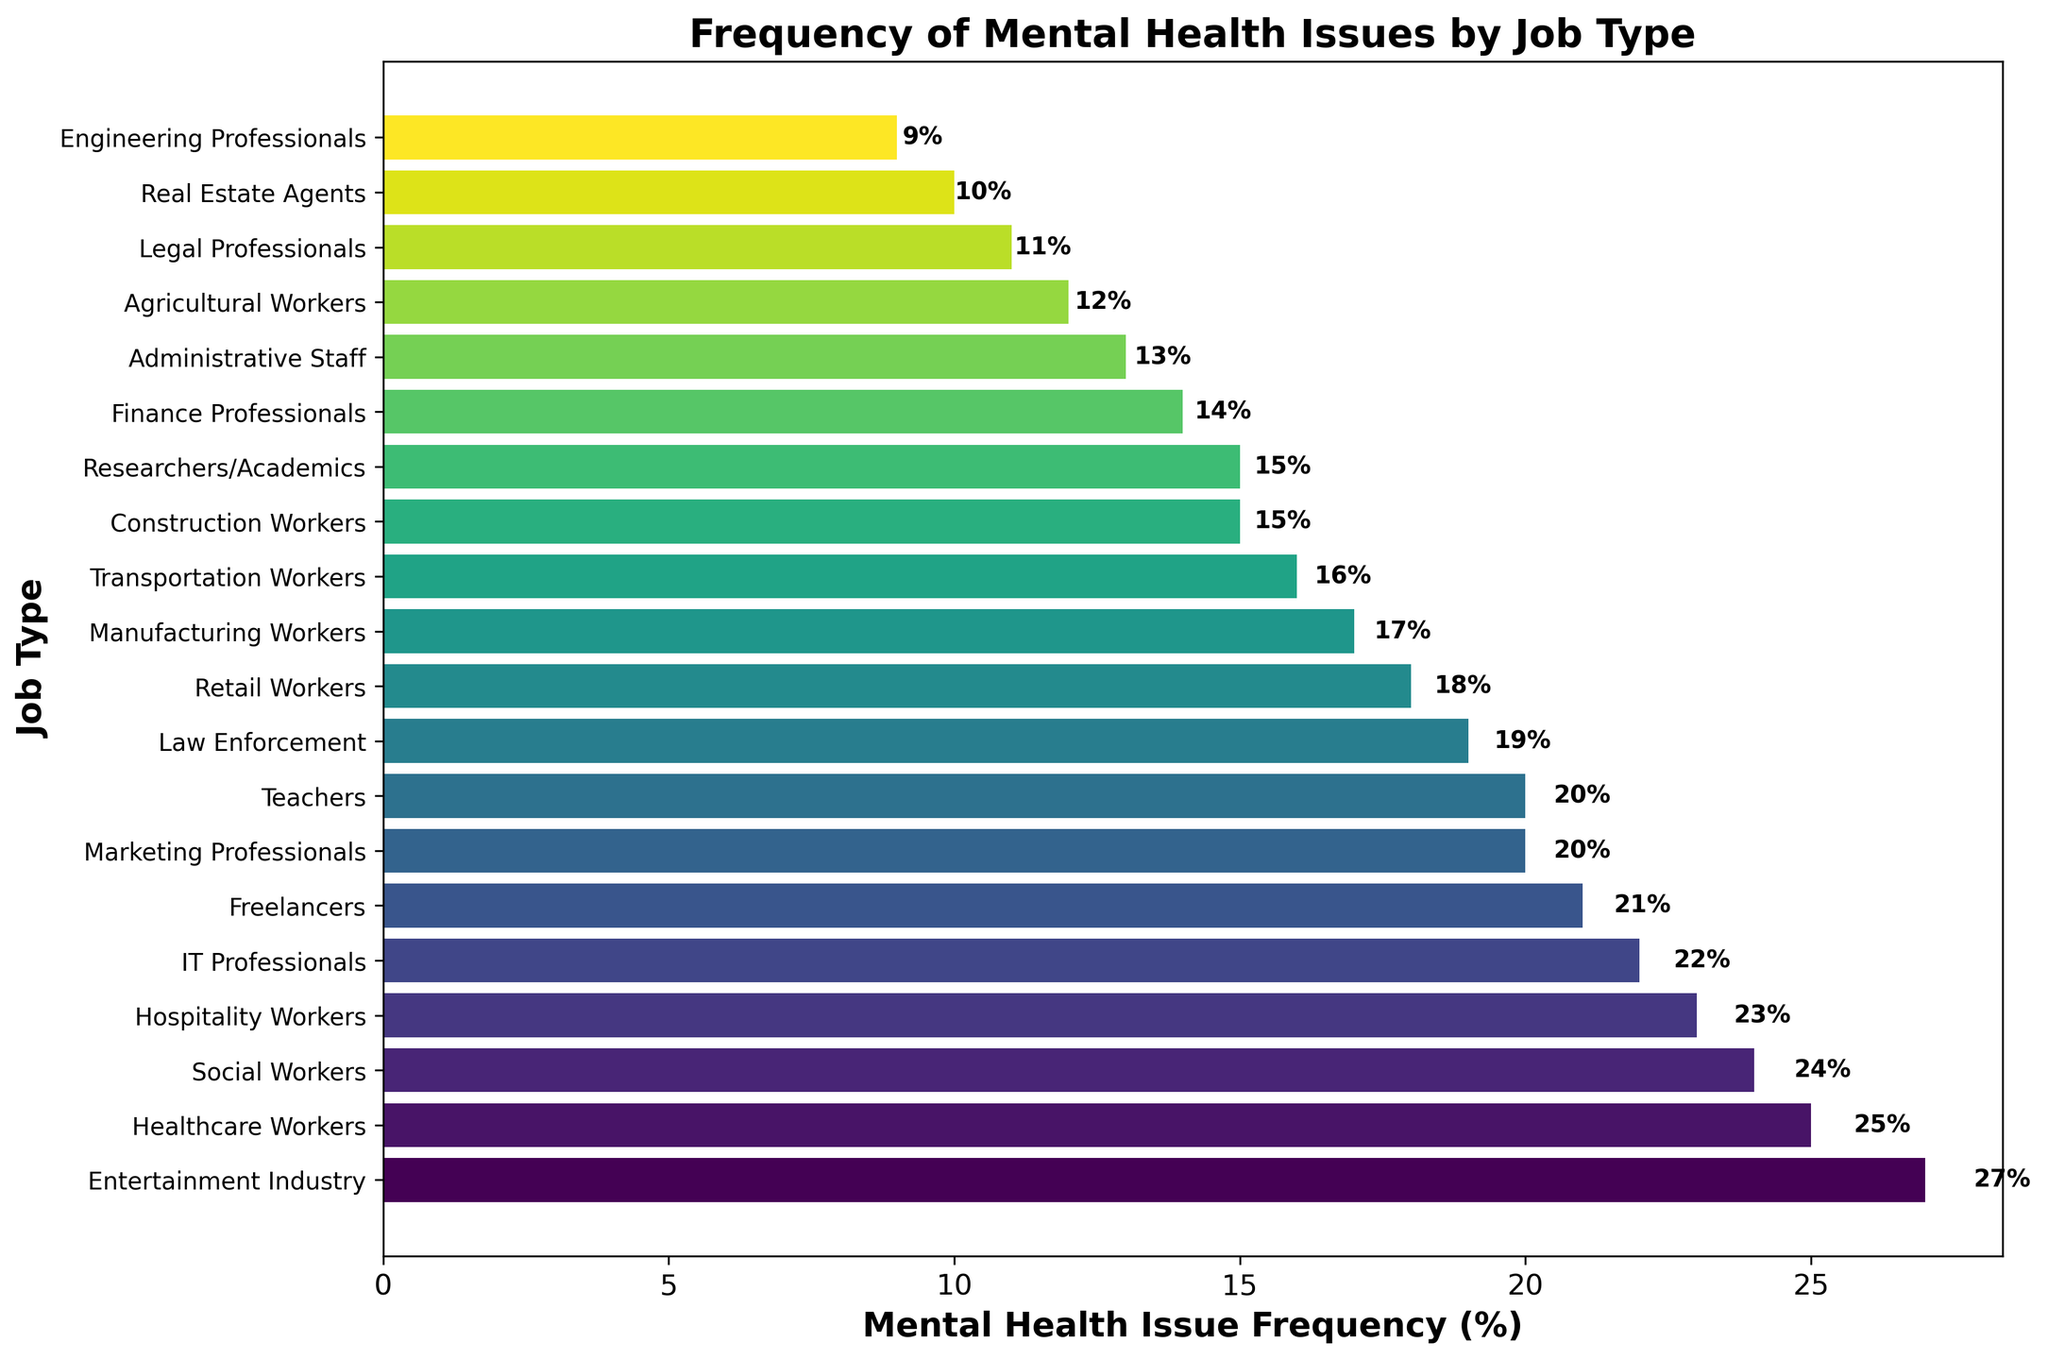Which job type has the highest frequency of mental health issues? By observing the lengths of the bars, the job type with the longest bar indicates the highest frequency. In this case, the Entertainment Industry has the longest bar.
Answer: Entertainment Industry Is the frequency of mental health issues for IT Professionals greater than for Teachers? By comparing the lengths of the bars for IT Professionals and Teachers, we see that IT Professionals have a frequency of 22%, while Teachers have 20%. Hence, the frequency for IT Professionals is greater.
Answer: Yes What is the difference in mental health issue frequency between Healthcare Workers and Real Estate Agents? The frequency for Healthcare Workers is 25%, and for Real Estate Agents, it is 10%. The difference is 25% - 10%.
Answer: 15% Which two job types have the closest frequency of mental health issues? By examining the bars closely, Social Workers (24%) and Healthcare Workers (25%) have the closest frequencies with a difference of just 1%.
Answer: Social Workers and Healthcare Workers What is the range of the mental health issue frequencies across all job types? The highest frequency is 27% (Entertainment Industry) and the lowest is 9% (Engineering Professionals). The range is 27% - 9%.
Answer: 18% What's the total frequency of mental health issues for Finance Professionals, Admin Staff, and Agricultural Workers combined? Summing the frequencies: Finance Professionals (14%), Admin Staff (13%), and Agricultural Workers (12%). 14% + 13% + 12% = 39%.
Answer: 39% How does the frequency of mental health issues for Legal Professionals compare to Transportation Workers? Legal Professionals have a frequency of 11%, while Transportation Workers have 16%. 16% is greater than 11%.
Answer: Transportation Workers have higher Which job type has the second-lowest frequency of mental health issues? The second shortest bar belongs to Legal Professionals, which has a frequency higher than Engineering Professionals.
Answer: Legal Professionals What is the average frequency of mental health issues for Retail Workers, Construction Workers, and Teachers? Calculate the average of the frequencies: Retail Workers (18%), Construction Workers (15%), and Teachers (20%). (18% + 15% + 20%) / 3 = 17.67%.
Answer: 17.67% Is the frequency of mental health issues for Freelancers closer to Healthcare Workers or Social Workers? Freelancers have a frequency of 21%. Healthcare Workers have 25%. Social Workers have 24%. The difference with Healthcare Workers is 25% - 21% = 4%, and the difference with Social Workers is 24% - 21% = 3%.
Answer: Social Workers 